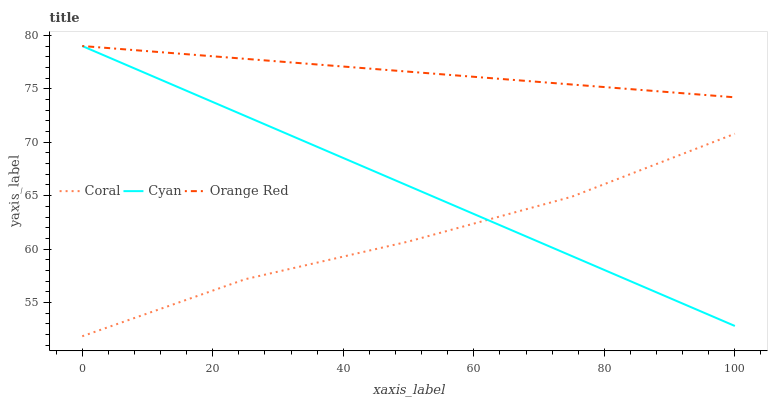Does Coral have the minimum area under the curve?
Answer yes or no. Yes. Does Orange Red have the maximum area under the curve?
Answer yes or no. Yes. Does Orange Red have the minimum area under the curve?
Answer yes or no. No. Does Coral have the maximum area under the curve?
Answer yes or no. No. Is Orange Red the smoothest?
Answer yes or no. Yes. Is Coral the roughest?
Answer yes or no. Yes. Is Coral the smoothest?
Answer yes or no. No. Is Orange Red the roughest?
Answer yes or no. No. Does Coral have the lowest value?
Answer yes or no. Yes. Does Orange Red have the lowest value?
Answer yes or no. No. Does Orange Red have the highest value?
Answer yes or no. Yes. Does Coral have the highest value?
Answer yes or no. No. Is Coral less than Orange Red?
Answer yes or no. Yes. Is Orange Red greater than Coral?
Answer yes or no. Yes. Does Orange Red intersect Cyan?
Answer yes or no. Yes. Is Orange Red less than Cyan?
Answer yes or no. No. Is Orange Red greater than Cyan?
Answer yes or no. No. Does Coral intersect Orange Red?
Answer yes or no. No. 